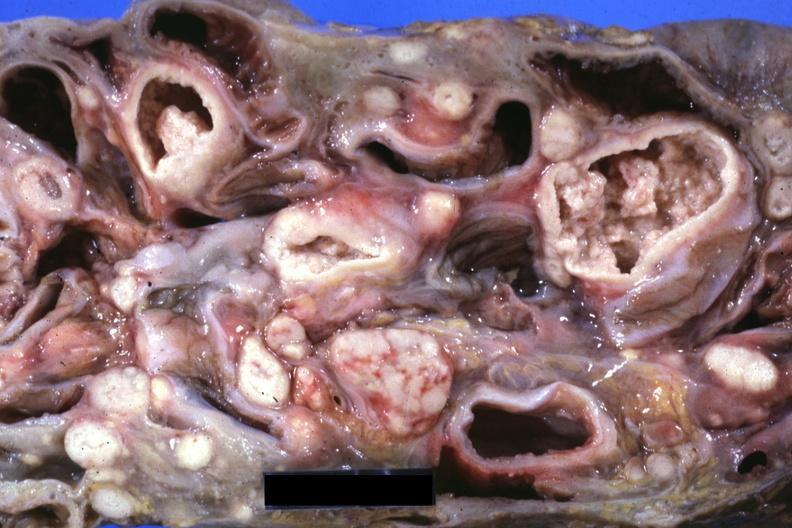what is mass of intestines and mesenteric nodes showing?
Answer the question using a single word or phrase. Lesions that look more like carcinoma but are in fact tuberculosis 